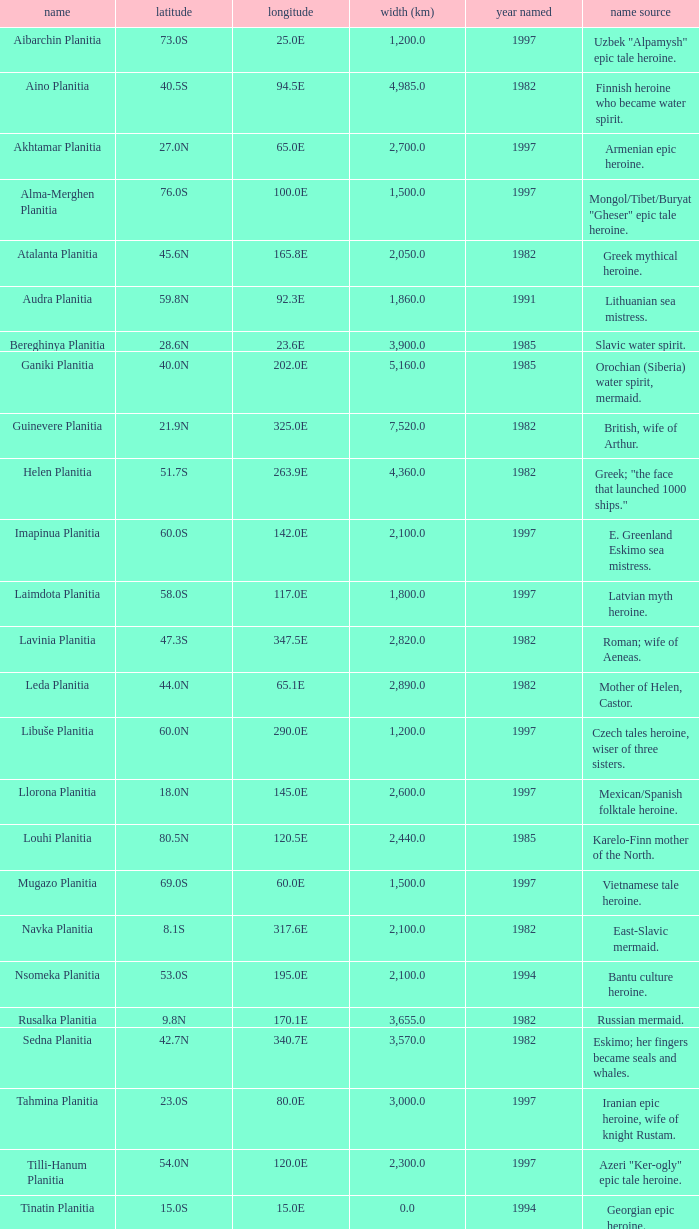What is the diameter (km) of feature of latitude 40.5s 4985.0. 